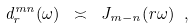Convert formula to latex. <formula><loc_0><loc_0><loc_500><loc_500>d ^ { m n } _ { r } ( \omega ) \ \asymp \ J _ { m - n } ( r \omega ) \ ,</formula> 